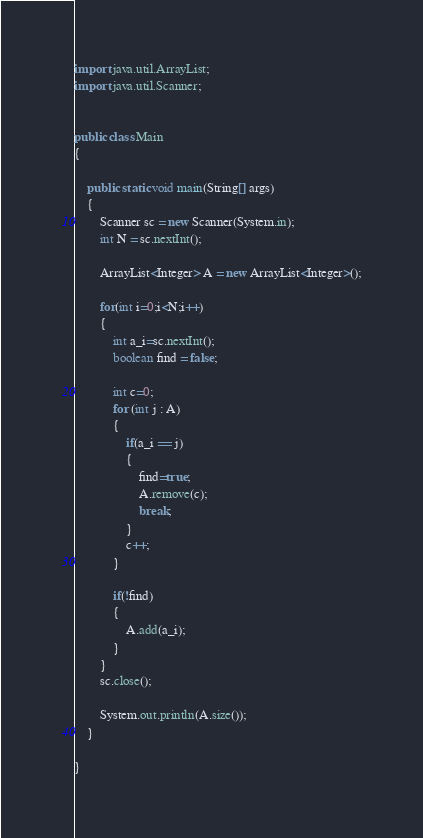<code> <loc_0><loc_0><loc_500><loc_500><_Java_>import java.util.ArrayList;
import java.util.Scanner;
 
 
public class Main 
{
 
	public static void main(String[] args) 
	{
		Scanner sc = new Scanner(System.in);
		int N = sc.nextInt();
 
		ArrayList<Integer> A = new ArrayList<Integer>();
		
		for(int i=0;i<N;i++)
		{
			int a_i=sc.nextInt();
			boolean find = false;
			
			int c=0;
			for (int j : A) 
			{
				if(a_i == j)
				{
					find=true;
					A.remove(c);
					break;
				}
				c++;
			}
			
			if(!find)
			{
				A.add(a_i);
			}
		}
		sc.close();
		
		System.out.println(A.size());
	}
 
}</code> 